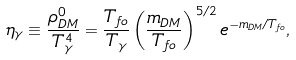<formula> <loc_0><loc_0><loc_500><loc_500>\eta _ { \gamma } \equiv \frac { \rho _ { D M } ^ { 0 } } { T _ { \gamma } ^ { 4 } } = \frac { T _ { f o } } { T _ { \gamma } } \left ( \frac { m _ { D M } } { T _ { f o } } \right ) ^ { 5 / 2 } e ^ { - m _ { D M } / T _ { f o } } ,</formula> 